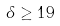<formula> <loc_0><loc_0><loc_500><loc_500>\delta \geq 1 9</formula> 